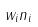Convert formula to latex. <formula><loc_0><loc_0><loc_500><loc_500>w _ { i } n _ { i }</formula> 